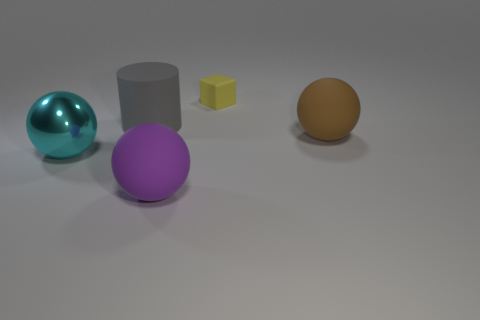Are there an equal number of cyan balls on the right side of the purple matte sphere and big cyan metallic things in front of the brown matte sphere? no 